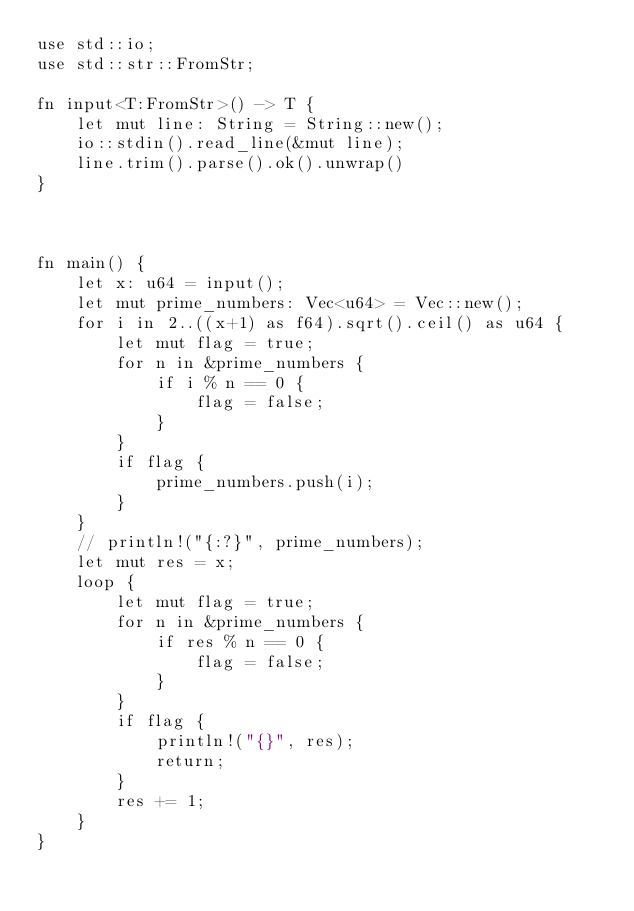Convert code to text. <code><loc_0><loc_0><loc_500><loc_500><_Rust_>use std::io;
use std::str::FromStr;

fn input<T:FromStr>() -> T {
    let mut line: String = String::new();
    io::stdin().read_line(&mut line);
    line.trim().parse().ok().unwrap()
}



fn main() {
    let x: u64 = input();
    let mut prime_numbers: Vec<u64> = Vec::new();
    for i in 2..((x+1) as f64).sqrt().ceil() as u64 {
        let mut flag = true;
        for n in &prime_numbers {
            if i % n == 0 {
                flag = false;
            }
        }
        if flag {
            prime_numbers.push(i);
        }
    }
    // println!("{:?}", prime_numbers);
    let mut res = x;
    loop {
        let mut flag = true;
        for n in &prime_numbers {            
            if res % n == 0 {
                flag = false;
            }
        }
        if flag {
            println!("{}", res);
            return;
        }
        res += 1;
    }
}
</code> 